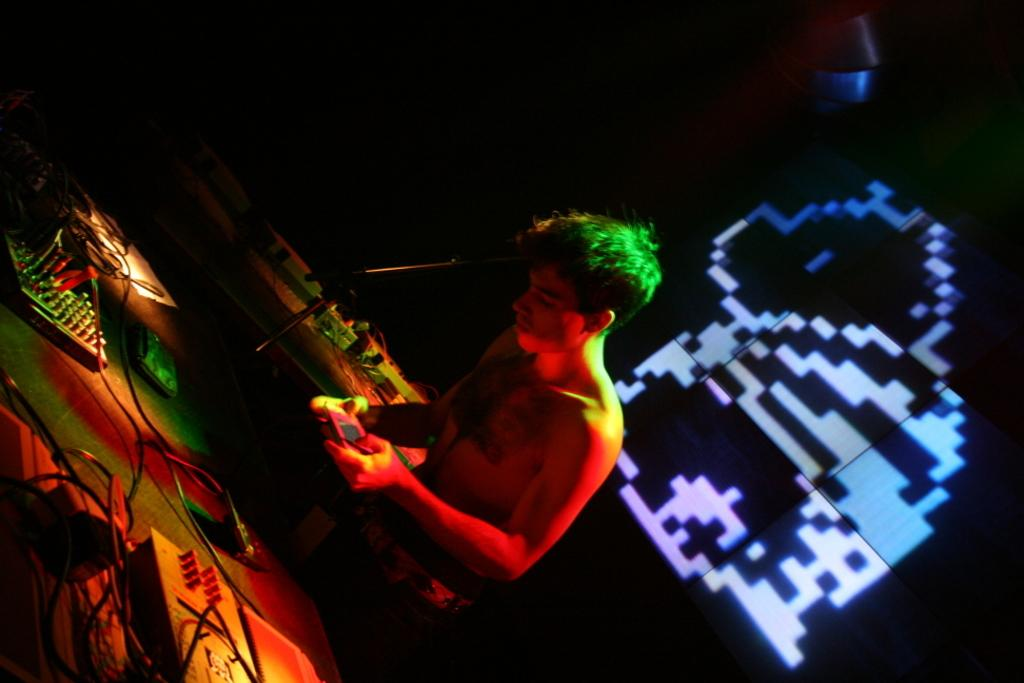What is the person in the image doing? The person is standing in the image and holding an object. What type of equipment can be seen in the image? There are DJ systems and cables visible in the image. What is present in the background of the image? There is a screen visible in the background of the image. Can you see a monkey playing with the cables in the image? No, there is no monkey present in the image. Is the maid visible in the image, cleaning the DJ systems? There is no maid present in the image. 